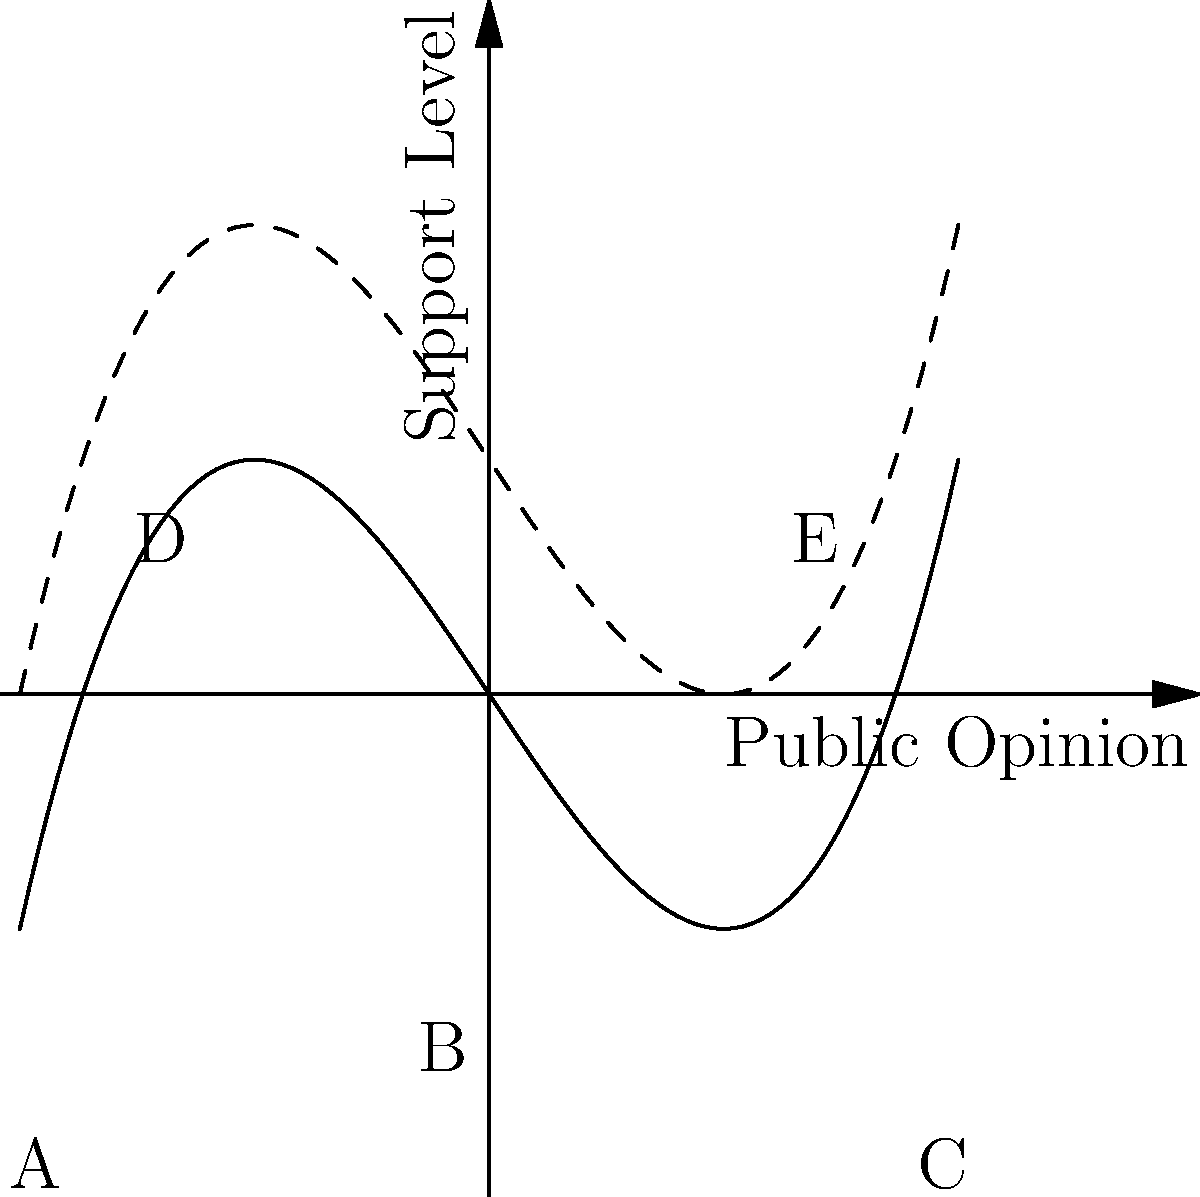In the context of applying Morse theory to visualize public opinion landscapes, analyze the graph above. Which points represent the critical points in public opinion, and what do they signify in terms of political strategy? To analyze this graph using Morse theory in the context of public opinion:

1. Identify the critical points:
   - Points A, B, and C on the solid curve
   - Points D and E on the dashed curve

2. Interpret the critical points:
   - Local minima (A and C): Represent stable positions of public opinion
   - Local maximum (B): Represents an unstable position or "tipping point"
   - Saddle points (D and E): Represent transition states or "swing" positions

3. Political strategy implications:
   - Stable positions (A and C): Require significant effort to shift public opinion
   - Tipping point (B): Small changes can lead to large shifts in opinion
   - Transition states (D and E): Areas where targeted campaigns can be most effective

4. The dashed curve represents a perturbed landscape, showing how external factors or campaign efforts can alter the opinion landscape.

5. The x-axis represents the spectrum of public opinion on an issue, while the y-axis shows the level of support or opposition.

6. Politicians and campaign strategists would focus on:
   - Reinforcing support at stable positions (A and C)
   - Pushing opinions past the tipping point (B)
   - Targeting efforts at transition states (D and E) for maximum impact

Understanding this landscape allows for more efficient allocation of campaign resources and more effective messaging strategies.
Answer: A, B, C (stable opinions, tipping point); D, E (transition states) 